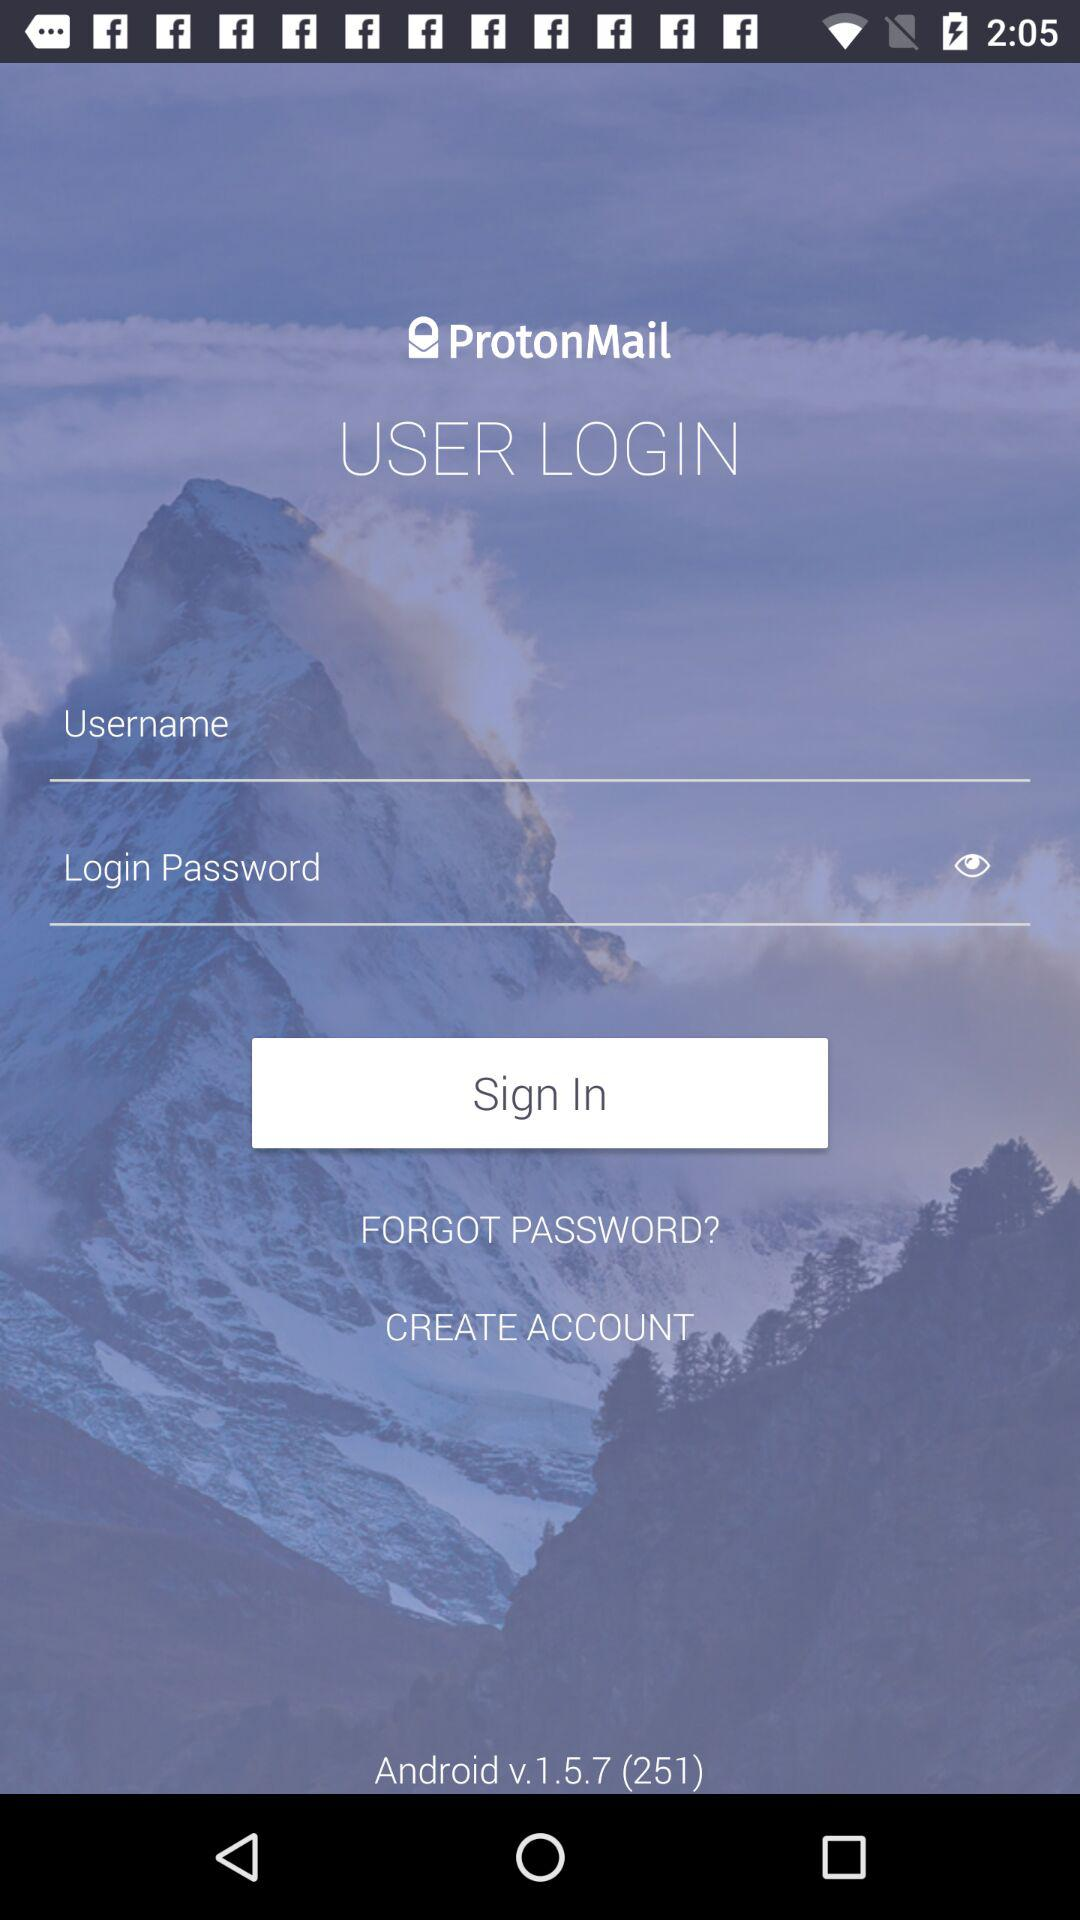What is the application name? The application name is "ProtonMail". 